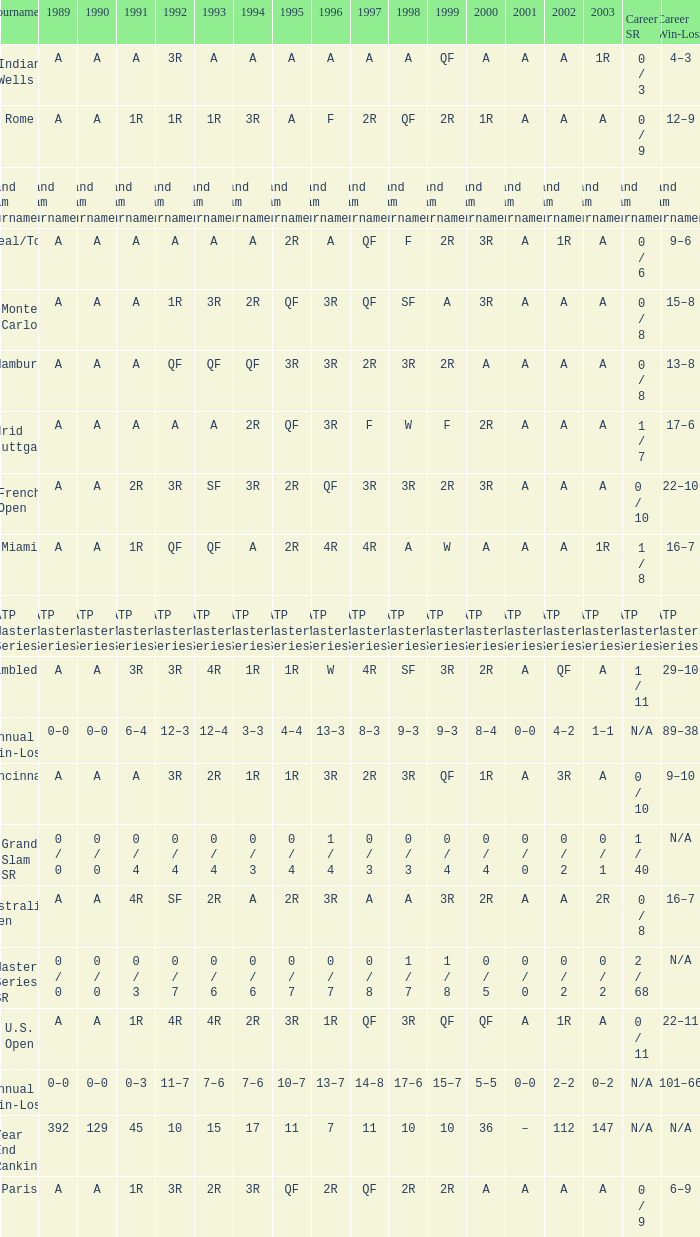What was the value in 1995 for A in 2000 at the Indian Wells tournament? A. 